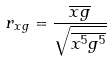Convert formula to latex. <formula><loc_0><loc_0><loc_500><loc_500>r _ { x g } = \frac { \overline { x g } } { \sqrt { \overline { x ^ { 5 } } \overline { g ^ { 5 } } } }</formula> 